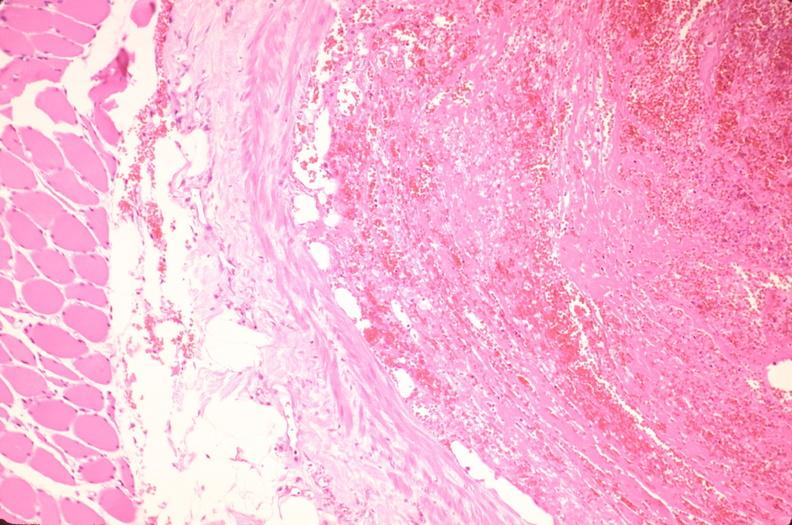s quite good liver present?
Answer the question using a single word or phrase. No 